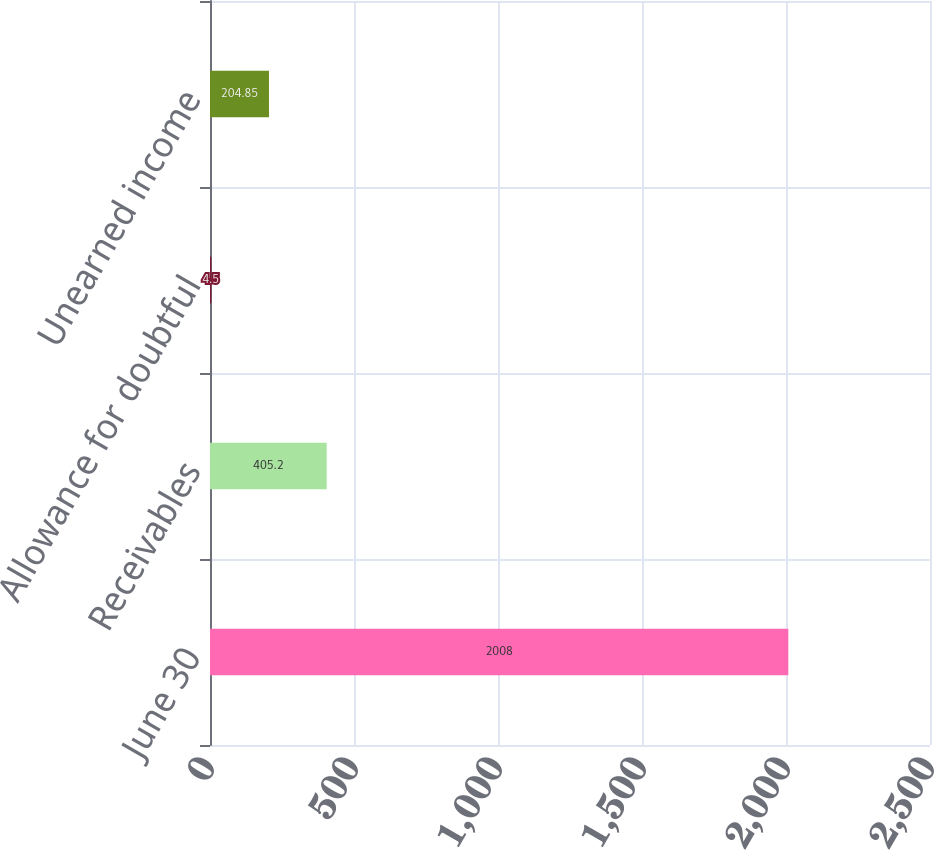Convert chart to OTSL. <chart><loc_0><loc_0><loc_500><loc_500><bar_chart><fcel>June 30<fcel>Receivables<fcel>Allowance for doubtful<fcel>Unearned income<nl><fcel>2008<fcel>405.2<fcel>4.5<fcel>204.85<nl></chart> 